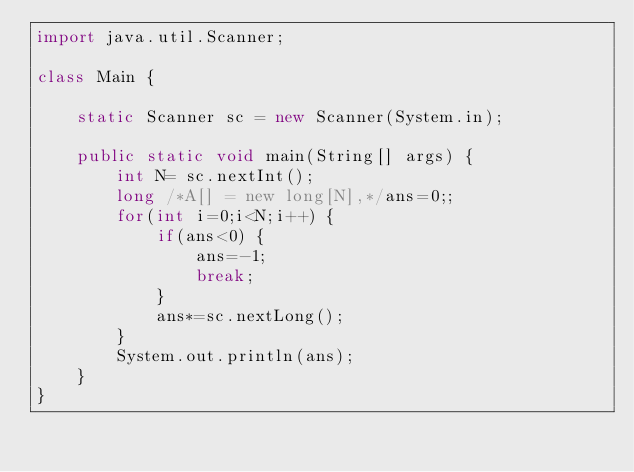<code> <loc_0><loc_0><loc_500><loc_500><_Java_>import java.util.Scanner;

class Main {

	static Scanner sc = new Scanner(System.in);

	public static void main(String[] args) {
		int N= sc.nextInt();
		long /*A[] = new long[N],*/ans=0;;
		for(int i=0;i<N;i++) {
			if(ans<0) {
				ans=-1;
				break;
			}
			ans*=sc.nextLong();
		}
		System.out.println(ans);
	}
}</code> 